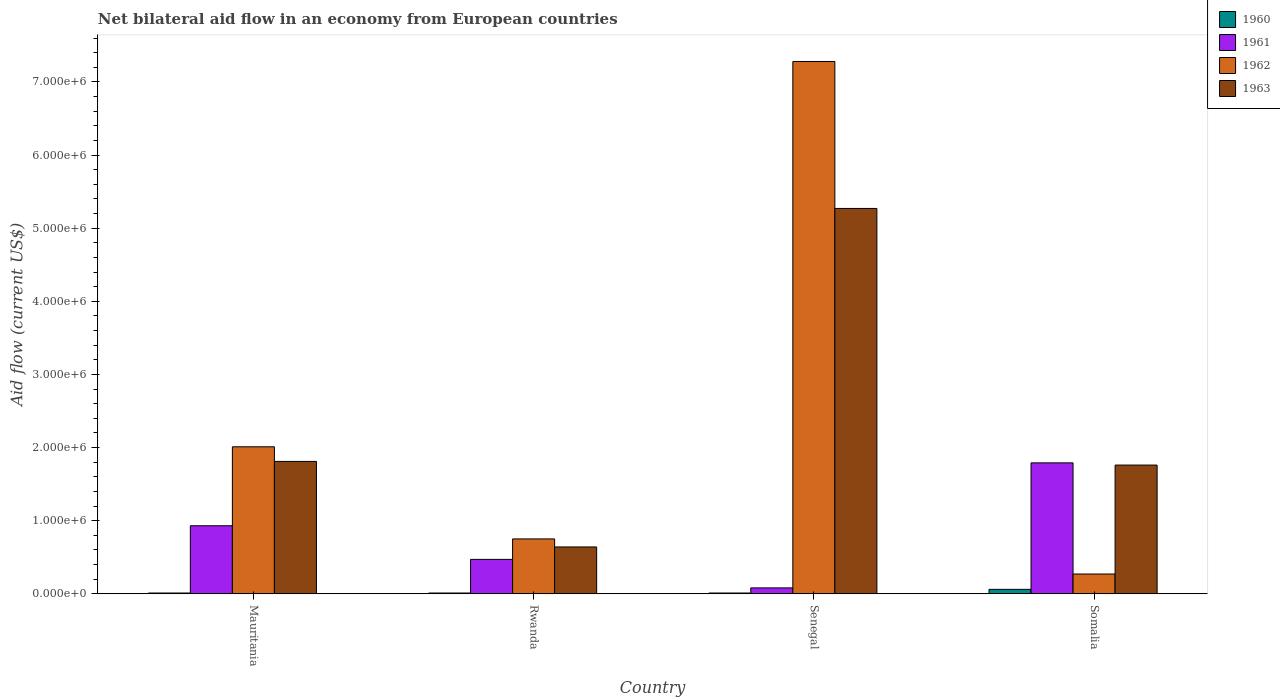How many different coloured bars are there?
Your answer should be compact. 4. How many groups of bars are there?
Keep it short and to the point. 4. How many bars are there on the 2nd tick from the left?
Your answer should be compact. 4. What is the label of the 4th group of bars from the left?
Provide a short and direct response. Somalia. Across all countries, what is the maximum net bilateral aid flow in 1962?
Your answer should be very brief. 7.28e+06. Across all countries, what is the minimum net bilateral aid flow in 1962?
Your response must be concise. 2.70e+05. In which country was the net bilateral aid flow in 1963 maximum?
Make the answer very short. Senegal. In which country was the net bilateral aid flow in 1963 minimum?
Make the answer very short. Rwanda. What is the total net bilateral aid flow in 1961 in the graph?
Keep it short and to the point. 3.27e+06. What is the difference between the net bilateral aid flow in 1962 in Mauritania and that in Rwanda?
Offer a terse response. 1.26e+06. What is the difference between the net bilateral aid flow in 1961 in Rwanda and the net bilateral aid flow in 1963 in Senegal?
Offer a very short reply. -4.80e+06. What is the average net bilateral aid flow in 1960 per country?
Provide a succinct answer. 2.25e+04. What is the difference between the net bilateral aid flow of/in 1960 and net bilateral aid flow of/in 1961 in Somalia?
Your response must be concise. -1.73e+06. What is the ratio of the net bilateral aid flow in 1963 in Rwanda to that in Senegal?
Provide a short and direct response. 0.12. What is the difference between the highest and the second highest net bilateral aid flow in 1961?
Ensure brevity in your answer.  1.32e+06. What is the difference between the highest and the lowest net bilateral aid flow in 1962?
Keep it short and to the point. 7.01e+06. In how many countries, is the net bilateral aid flow in 1961 greater than the average net bilateral aid flow in 1961 taken over all countries?
Provide a succinct answer. 2. Is the sum of the net bilateral aid flow in 1961 in Rwanda and Somalia greater than the maximum net bilateral aid flow in 1963 across all countries?
Your answer should be very brief. No. Is it the case that in every country, the sum of the net bilateral aid flow in 1962 and net bilateral aid flow in 1963 is greater than the sum of net bilateral aid flow in 1960 and net bilateral aid flow in 1961?
Ensure brevity in your answer.  Yes. What does the 3rd bar from the right in Senegal represents?
Give a very brief answer. 1961. Are all the bars in the graph horizontal?
Give a very brief answer. No. How many countries are there in the graph?
Your response must be concise. 4. What is the difference between two consecutive major ticks on the Y-axis?
Give a very brief answer. 1.00e+06. Does the graph contain any zero values?
Offer a very short reply. No. How are the legend labels stacked?
Provide a short and direct response. Vertical. What is the title of the graph?
Your response must be concise. Net bilateral aid flow in an economy from European countries. Does "1963" appear as one of the legend labels in the graph?
Provide a succinct answer. Yes. What is the label or title of the Y-axis?
Your answer should be compact. Aid flow (current US$). What is the Aid flow (current US$) of 1960 in Mauritania?
Your answer should be very brief. 10000. What is the Aid flow (current US$) of 1961 in Mauritania?
Your answer should be compact. 9.30e+05. What is the Aid flow (current US$) of 1962 in Mauritania?
Provide a short and direct response. 2.01e+06. What is the Aid flow (current US$) in 1963 in Mauritania?
Your response must be concise. 1.81e+06. What is the Aid flow (current US$) in 1960 in Rwanda?
Make the answer very short. 10000. What is the Aid flow (current US$) of 1961 in Rwanda?
Your response must be concise. 4.70e+05. What is the Aid flow (current US$) in 1962 in Rwanda?
Offer a very short reply. 7.50e+05. What is the Aid flow (current US$) of 1963 in Rwanda?
Provide a short and direct response. 6.40e+05. What is the Aid flow (current US$) of 1962 in Senegal?
Offer a very short reply. 7.28e+06. What is the Aid flow (current US$) of 1963 in Senegal?
Provide a short and direct response. 5.27e+06. What is the Aid flow (current US$) in 1961 in Somalia?
Offer a terse response. 1.79e+06. What is the Aid flow (current US$) of 1963 in Somalia?
Your answer should be very brief. 1.76e+06. Across all countries, what is the maximum Aid flow (current US$) in 1961?
Give a very brief answer. 1.79e+06. Across all countries, what is the maximum Aid flow (current US$) in 1962?
Offer a terse response. 7.28e+06. Across all countries, what is the maximum Aid flow (current US$) of 1963?
Your response must be concise. 5.27e+06. Across all countries, what is the minimum Aid flow (current US$) in 1960?
Offer a terse response. 10000. Across all countries, what is the minimum Aid flow (current US$) in 1962?
Give a very brief answer. 2.70e+05. Across all countries, what is the minimum Aid flow (current US$) in 1963?
Make the answer very short. 6.40e+05. What is the total Aid flow (current US$) in 1961 in the graph?
Make the answer very short. 3.27e+06. What is the total Aid flow (current US$) of 1962 in the graph?
Give a very brief answer. 1.03e+07. What is the total Aid flow (current US$) in 1963 in the graph?
Offer a terse response. 9.48e+06. What is the difference between the Aid flow (current US$) in 1960 in Mauritania and that in Rwanda?
Make the answer very short. 0. What is the difference between the Aid flow (current US$) in 1961 in Mauritania and that in Rwanda?
Your answer should be very brief. 4.60e+05. What is the difference between the Aid flow (current US$) in 1962 in Mauritania and that in Rwanda?
Provide a short and direct response. 1.26e+06. What is the difference between the Aid flow (current US$) in 1963 in Mauritania and that in Rwanda?
Keep it short and to the point. 1.17e+06. What is the difference between the Aid flow (current US$) in 1960 in Mauritania and that in Senegal?
Provide a short and direct response. 0. What is the difference between the Aid flow (current US$) of 1961 in Mauritania and that in Senegal?
Your response must be concise. 8.50e+05. What is the difference between the Aid flow (current US$) in 1962 in Mauritania and that in Senegal?
Give a very brief answer. -5.27e+06. What is the difference between the Aid flow (current US$) in 1963 in Mauritania and that in Senegal?
Provide a succinct answer. -3.46e+06. What is the difference between the Aid flow (current US$) in 1960 in Mauritania and that in Somalia?
Keep it short and to the point. -5.00e+04. What is the difference between the Aid flow (current US$) in 1961 in Mauritania and that in Somalia?
Make the answer very short. -8.60e+05. What is the difference between the Aid flow (current US$) in 1962 in Mauritania and that in Somalia?
Your response must be concise. 1.74e+06. What is the difference between the Aid flow (current US$) in 1963 in Mauritania and that in Somalia?
Provide a succinct answer. 5.00e+04. What is the difference between the Aid flow (current US$) of 1960 in Rwanda and that in Senegal?
Offer a very short reply. 0. What is the difference between the Aid flow (current US$) in 1962 in Rwanda and that in Senegal?
Provide a short and direct response. -6.53e+06. What is the difference between the Aid flow (current US$) in 1963 in Rwanda and that in Senegal?
Your response must be concise. -4.63e+06. What is the difference between the Aid flow (current US$) of 1960 in Rwanda and that in Somalia?
Your answer should be very brief. -5.00e+04. What is the difference between the Aid flow (current US$) in 1961 in Rwanda and that in Somalia?
Give a very brief answer. -1.32e+06. What is the difference between the Aid flow (current US$) of 1962 in Rwanda and that in Somalia?
Provide a succinct answer. 4.80e+05. What is the difference between the Aid flow (current US$) in 1963 in Rwanda and that in Somalia?
Give a very brief answer. -1.12e+06. What is the difference between the Aid flow (current US$) in 1961 in Senegal and that in Somalia?
Ensure brevity in your answer.  -1.71e+06. What is the difference between the Aid flow (current US$) in 1962 in Senegal and that in Somalia?
Offer a terse response. 7.01e+06. What is the difference between the Aid flow (current US$) in 1963 in Senegal and that in Somalia?
Provide a short and direct response. 3.51e+06. What is the difference between the Aid flow (current US$) of 1960 in Mauritania and the Aid flow (current US$) of 1961 in Rwanda?
Offer a terse response. -4.60e+05. What is the difference between the Aid flow (current US$) in 1960 in Mauritania and the Aid flow (current US$) in 1962 in Rwanda?
Offer a very short reply. -7.40e+05. What is the difference between the Aid flow (current US$) in 1960 in Mauritania and the Aid flow (current US$) in 1963 in Rwanda?
Give a very brief answer. -6.30e+05. What is the difference between the Aid flow (current US$) in 1961 in Mauritania and the Aid flow (current US$) in 1962 in Rwanda?
Give a very brief answer. 1.80e+05. What is the difference between the Aid flow (current US$) of 1961 in Mauritania and the Aid flow (current US$) of 1963 in Rwanda?
Your response must be concise. 2.90e+05. What is the difference between the Aid flow (current US$) in 1962 in Mauritania and the Aid flow (current US$) in 1963 in Rwanda?
Provide a short and direct response. 1.37e+06. What is the difference between the Aid flow (current US$) of 1960 in Mauritania and the Aid flow (current US$) of 1962 in Senegal?
Offer a very short reply. -7.27e+06. What is the difference between the Aid flow (current US$) in 1960 in Mauritania and the Aid flow (current US$) in 1963 in Senegal?
Provide a succinct answer. -5.26e+06. What is the difference between the Aid flow (current US$) in 1961 in Mauritania and the Aid flow (current US$) in 1962 in Senegal?
Give a very brief answer. -6.35e+06. What is the difference between the Aid flow (current US$) in 1961 in Mauritania and the Aid flow (current US$) in 1963 in Senegal?
Offer a terse response. -4.34e+06. What is the difference between the Aid flow (current US$) in 1962 in Mauritania and the Aid flow (current US$) in 1963 in Senegal?
Your response must be concise. -3.26e+06. What is the difference between the Aid flow (current US$) of 1960 in Mauritania and the Aid flow (current US$) of 1961 in Somalia?
Keep it short and to the point. -1.78e+06. What is the difference between the Aid flow (current US$) in 1960 in Mauritania and the Aid flow (current US$) in 1962 in Somalia?
Offer a terse response. -2.60e+05. What is the difference between the Aid flow (current US$) in 1960 in Mauritania and the Aid flow (current US$) in 1963 in Somalia?
Offer a very short reply. -1.75e+06. What is the difference between the Aid flow (current US$) in 1961 in Mauritania and the Aid flow (current US$) in 1962 in Somalia?
Make the answer very short. 6.60e+05. What is the difference between the Aid flow (current US$) in 1961 in Mauritania and the Aid flow (current US$) in 1963 in Somalia?
Make the answer very short. -8.30e+05. What is the difference between the Aid flow (current US$) in 1960 in Rwanda and the Aid flow (current US$) in 1961 in Senegal?
Offer a terse response. -7.00e+04. What is the difference between the Aid flow (current US$) in 1960 in Rwanda and the Aid flow (current US$) in 1962 in Senegal?
Provide a succinct answer. -7.27e+06. What is the difference between the Aid flow (current US$) in 1960 in Rwanda and the Aid flow (current US$) in 1963 in Senegal?
Ensure brevity in your answer.  -5.26e+06. What is the difference between the Aid flow (current US$) in 1961 in Rwanda and the Aid flow (current US$) in 1962 in Senegal?
Give a very brief answer. -6.81e+06. What is the difference between the Aid flow (current US$) in 1961 in Rwanda and the Aid flow (current US$) in 1963 in Senegal?
Keep it short and to the point. -4.80e+06. What is the difference between the Aid flow (current US$) of 1962 in Rwanda and the Aid flow (current US$) of 1963 in Senegal?
Your response must be concise. -4.52e+06. What is the difference between the Aid flow (current US$) in 1960 in Rwanda and the Aid flow (current US$) in 1961 in Somalia?
Make the answer very short. -1.78e+06. What is the difference between the Aid flow (current US$) of 1960 in Rwanda and the Aid flow (current US$) of 1963 in Somalia?
Your response must be concise. -1.75e+06. What is the difference between the Aid flow (current US$) of 1961 in Rwanda and the Aid flow (current US$) of 1963 in Somalia?
Your answer should be very brief. -1.29e+06. What is the difference between the Aid flow (current US$) of 1962 in Rwanda and the Aid flow (current US$) of 1963 in Somalia?
Provide a succinct answer. -1.01e+06. What is the difference between the Aid flow (current US$) in 1960 in Senegal and the Aid flow (current US$) in 1961 in Somalia?
Ensure brevity in your answer.  -1.78e+06. What is the difference between the Aid flow (current US$) in 1960 in Senegal and the Aid flow (current US$) in 1963 in Somalia?
Ensure brevity in your answer.  -1.75e+06. What is the difference between the Aid flow (current US$) of 1961 in Senegal and the Aid flow (current US$) of 1962 in Somalia?
Your response must be concise. -1.90e+05. What is the difference between the Aid flow (current US$) of 1961 in Senegal and the Aid flow (current US$) of 1963 in Somalia?
Keep it short and to the point. -1.68e+06. What is the difference between the Aid flow (current US$) in 1962 in Senegal and the Aid flow (current US$) in 1963 in Somalia?
Keep it short and to the point. 5.52e+06. What is the average Aid flow (current US$) of 1960 per country?
Provide a short and direct response. 2.25e+04. What is the average Aid flow (current US$) of 1961 per country?
Your response must be concise. 8.18e+05. What is the average Aid flow (current US$) of 1962 per country?
Your answer should be very brief. 2.58e+06. What is the average Aid flow (current US$) in 1963 per country?
Offer a very short reply. 2.37e+06. What is the difference between the Aid flow (current US$) of 1960 and Aid flow (current US$) of 1961 in Mauritania?
Keep it short and to the point. -9.20e+05. What is the difference between the Aid flow (current US$) in 1960 and Aid flow (current US$) in 1962 in Mauritania?
Your answer should be compact. -2.00e+06. What is the difference between the Aid flow (current US$) in 1960 and Aid flow (current US$) in 1963 in Mauritania?
Your answer should be very brief. -1.80e+06. What is the difference between the Aid flow (current US$) in 1961 and Aid flow (current US$) in 1962 in Mauritania?
Offer a terse response. -1.08e+06. What is the difference between the Aid flow (current US$) in 1961 and Aid flow (current US$) in 1963 in Mauritania?
Provide a succinct answer. -8.80e+05. What is the difference between the Aid flow (current US$) in 1962 and Aid flow (current US$) in 1963 in Mauritania?
Make the answer very short. 2.00e+05. What is the difference between the Aid flow (current US$) of 1960 and Aid flow (current US$) of 1961 in Rwanda?
Your answer should be compact. -4.60e+05. What is the difference between the Aid flow (current US$) in 1960 and Aid flow (current US$) in 1962 in Rwanda?
Keep it short and to the point. -7.40e+05. What is the difference between the Aid flow (current US$) of 1960 and Aid flow (current US$) of 1963 in Rwanda?
Provide a short and direct response. -6.30e+05. What is the difference between the Aid flow (current US$) in 1961 and Aid flow (current US$) in 1962 in Rwanda?
Provide a short and direct response. -2.80e+05. What is the difference between the Aid flow (current US$) in 1961 and Aid flow (current US$) in 1963 in Rwanda?
Keep it short and to the point. -1.70e+05. What is the difference between the Aid flow (current US$) of 1962 and Aid flow (current US$) of 1963 in Rwanda?
Ensure brevity in your answer.  1.10e+05. What is the difference between the Aid flow (current US$) in 1960 and Aid flow (current US$) in 1961 in Senegal?
Offer a very short reply. -7.00e+04. What is the difference between the Aid flow (current US$) in 1960 and Aid flow (current US$) in 1962 in Senegal?
Offer a very short reply. -7.27e+06. What is the difference between the Aid flow (current US$) of 1960 and Aid flow (current US$) of 1963 in Senegal?
Make the answer very short. -5.26e+06. What is the difference between the Aid flow (current US$) in 1961 and Aid flow (current US$) in 1962 in Senegal?
Keep it short and to the point. -7.20e+06. What is the difference between the Aid flow (current US$) in 1961 and Aid flow (current US$) in 1963 in Senegal?
Offer a very short reply. -5.19e+06. What is the difference between the Aid flow (current US$) in 1962 and Aid flow (current US$) in 1963 in Senegal?
Keep it short and to the point. 2.01e+06. What is the difference between the Aid flow (current US$) in 1960 and Aid flow (current US$) in 1961 in Somalia?
Your answer should be compact. -1.73e+06. What is the difference between the Aid flow (current US$) in 1960 and Aid flow (current US$) in 1962 in Somalia?
Keep it short and to the point. -2.10e+05. What is the difference between the Aid flow (current US$) in 1960 and Aid flow (current US$) in 1963 in Somalia?
Offer a very short reply. -1.70e+06. What is the difference between the Aid flow (current US$) in 1961 and Aid flow (current US$) in 1962 in Somalia?
Provide a short and direct response. 1.52e+06. What is the difference between the Aid flow (current US$) in 1962 and Aid flow (current US$) in 1963 in Somalia?
Your answer should be very brief. -1.49e+06. What is the ratio of the Aid flow (current US$) of 1961 in Mauritania to that in Rwanda?
Offer a very short reply. 1.98. What is the ratio of the Aid flow (current US$) of 1962 in Mauritania to that in Rwanda?
Make the answer very short. 2.68. What is the ratio of the Aid flow (current US$) of 1963 in Mauritania to that in Rwanda?
Provide a short and direct response. 2.83. What is the ratio of the Aid flow (current US$) in 1960 in Mauritania to that in Senegal?
Offer a terse response. 1. What is the ratio of the Aid flow (current US$) in 1961 in Mauritania to that in Senegal?
Keep it short and to the point. 11.62. What is the ratio of the Aid flow (current US$) of 1962 in Mauritania to that in Senegal?
Your answer should be very brief. 0.28. What is the ratio of the Aid flow (current US$) in 1963 in Mauritania to that in Senegal?
Your answer should be compact. 0.34. What is the ratio of the Aid flow (current US$) in 1960 in Mauritania to that in Somalia?
Ensure brevity in your answer.  0.17. What is the ratio of the Aid flow (current US$) in 1961 in Mauritania to that in Somalia?
Provide a succinct answer. 0.52. What is the ratio of the Aid flow (current US$) of 1962 in Mauritania to that in Somalia?
Keep it short and to the point. 7.44. What is the ratio of the Aid flow (current US$) in 1963 in Mauritania to that in Somalia?
Keep it short and to the point. 1.03. What is the ratio of the Aid flow (current US$) in 1961 in Rwanda to that in Senegal?
Offer a terse response. 5.88. What is the ratio of the Aid flow (current US$) in 1962 in Rwanda to that in Senegal?
Keep it short and to the point. 0.1. What is the ratio of the Aid flow (current US$) of 1963 in Rwanda to that in Senegal?
Make the answer very short. 0.12. What is the ratio of the Aid flow (current US$) of 1960 in Rwanda to that in Somalia?
Make the answer very short. 0.17. What is the ratio of the Aid flow (current US$) in 1961 in Rwanda to that in Somalia?
Provide a short and direct response. 0.26. What is the ratio of the Aid flow (current US$) in 1962 in Rwanda to that in Somalia?
Offer a very short reply. 2.78. What is the ratio of the Aid flow (current US$) in 1963 in Rwanda to that in Somalia?
Your answer should be compact. 0.36. What is the ratio of the Aid flow (current US$) of 1961 in Senegal to that in Somalia?
Your answer should be very brief. 0.04. What is the ratio of the Aid flow (current US$) in 1962 in Senegal to that in Somalia?
Your answer should be very brief. 26.96. What is the ratio of the Aid flow (current US$) of 1963 in Senegal to that in Somalia?
Your answer should be very brief. 2.99. What is the difference between the highest and the second highest Aid flow (current US$) of 1961?
Offer a terse response. 8.60e+05. What is the difference between the highest and the second highest Aid flow (current US$) in 1962?
Your response must be concise. 5.27e+06. What is the difference between the highest and the second highest Aid flow (current US$) in 1963?
Your answer should be compact. 3.46e+06. What is the difference between the highest and the lowest Aid flow (current US$) in 1961?
Keep it short and to the point. 1.71e+06. What is the difference between the highest and the lowest Aid flow (current US$) in 1962?
Provide a short and direct response. 7.01e+06. What is the difference between the highest and the lowest Aid flow (current US$) of 1963?
Your response must be concise. 4.63e+06. 